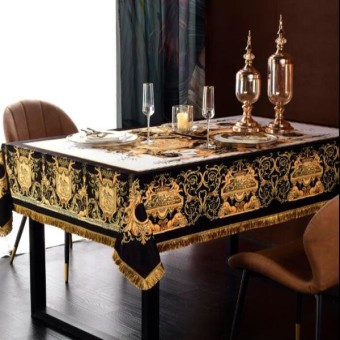What can you tell me about the lighting and mood of the scene? The image exhibits a warm and intimate ambiance, possibly created by soft, indirect lighting that might be coming from outside the frame. The dark background and dim setting convey a sense of privacy and exclusivity, enhancing the mood for a serene and luxurious dining experience. 